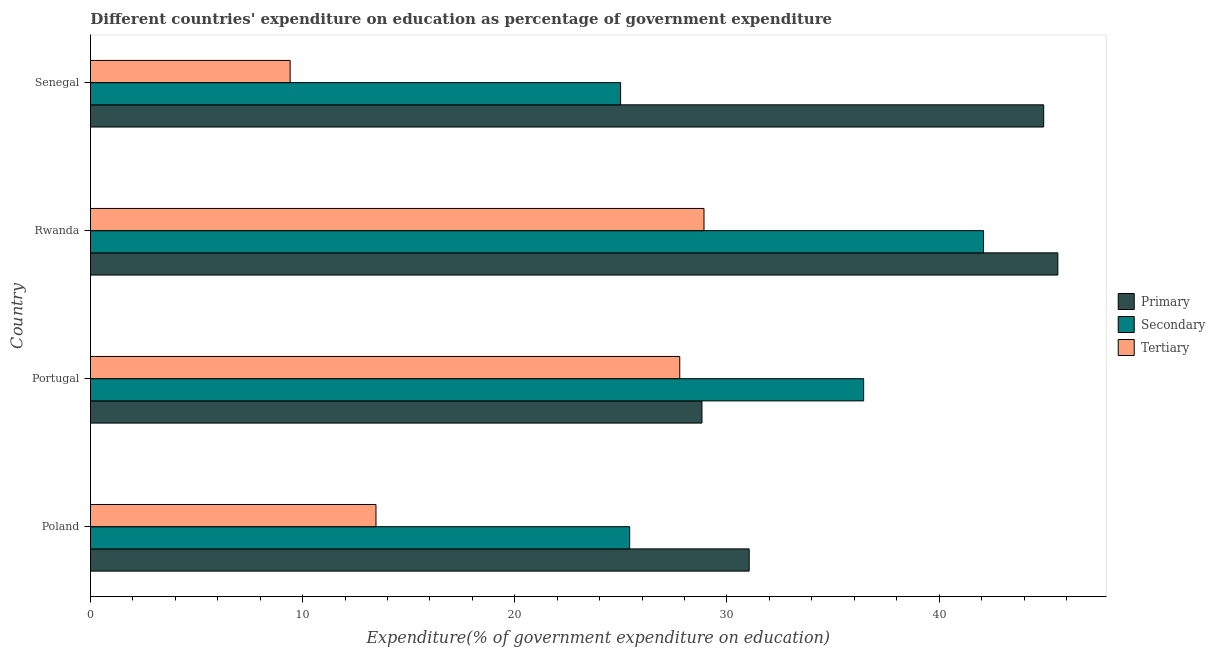How many groups of bars are there?
Keep it short and to the point. 4. Are the number of bars per tick equal to the number of legend labels?
Keep it short and to the point. Yes. What is the label of the 1st group of bars from the top?
Give a very brief answer. Senegal. What is the expenditure on tertiary education in Poland?
Your response must be concise. 13.46. Across all countries, what is the maximum expenditure on secondary education?
Ensure brevity in your answer.  42.09. Across all countries, what is the minimum expenditure on tertiary education?
Your answer should be very brief. 9.41. In which country was the expenditure on primary education maximum?
Ensure brevity in your answer.  Rwanda. In which country was the expenditure on tertiary education minimum?
Your answer should be compact. Senegal. What is the total expenditure on tertiary education in the graph?
Offer a terse response. 79.56. What is the difference between the expenditure on primary education in Rwanda and that in Senegal?
Provide a short and direct response. 0.67. What is the difference between the expenditure on tertiary education in Poland and the expenditure on secondary education in Rwanda?
Your response must be concise. -28.64. What is the average expenditure on primary education per country?
Ensure brevity in your answer.  37.6. What is the difference between the expenditure on tertiary education and expenditure on primary education in Senegal?
Give a very brief answer. -35.52. What is the ratio of the expenditure on tertiary education in Rwanda to that in Senegal?
Give a very brief answer. 3.07. Is the expenditure on tertiary education in Poland less than that in Senegal?
Make the answer very short. No. Is the difference between the expenditure on primary education in Poland and Senegal greater than the difference between the expenditure on tertiary education in Poland and Senegal?
Give a very brief answer. No. What is the difference between the highest and the second highest expenditure on primary education?
Give a very brief answer. 0.67. What is the difference between the highest and the lowest expenditure on secondary education?
Make the answer very short. 17.11. In how many countries, is the expenditure on primary education greater than the average expenditure on primary education taken over all countries?
Provide a short and direct response. 2. What does the 3rd bar from the top in Poland represents?
Give a very brief answer. Primary. What does the 3rd bar from the bottom in Senegal represents?
Offer a terse response. Tertiary. Is it the case that in every country, the sum of the expenditure on primary education and expenditure on secondary education is greater than the expenditure on tertiary education?
Your response must be concise. Yes. How many bars are there?
Give a very brief answer. 12. Are all the bars in the graph horizontal?
Provide a short and direct response. Yes. Does the graph contain any zero values?
Offer a very short reply. No. How many legend labels are there?
Offer a very short reply. 3. How are the legend labels stacked?
Your answer should be compact. Vertical. What is the title of the graph?
Your answer should be very brief. Different countries' expenditure on education as percentage of government expenditure. Does "Taxes on income" appear as one of the legend labels in the graph?
Provide a succinct answer. No. What is the label or title of the X-axis?
Your answer should be compact. Expenditure(% of government expenditure on education). What is the Expenditure(% of government expenditure on education) in Primary in Poland?
Give a very brief answer. 31.05. What is the Expenditure(% of government expenditure on education) in Secondary in Poland?
Keep it short and to the point. 25.41. What is the Expenditure(% of government expenditure on education) in Tertiary in Poland?
Make the answer very short. 13.46. What is the Expenditure(% of government expenditure on education) of Primary in Portugal?
Offer a terse response. 28.82. What is the Expenditure(% of government expenditure on education) in Secondary in Portugal?
Ensure brevity in your answer.  36.44. What is the Expenditure(% of government expenditure on education) of Tertiary in Portugal?
Provide a short and direct response. 27.77. What is the Expenditure(% of government expenditure on education) of Primary in Rwanda?
Ensure brevity in your answer.  45.6. What is the Expenditure(% of government expenditure on education) of Secondary in Rwanda?
Your response must be concise. 42.09. What is the Expenditure(% of government expenditure on education) of Tertiary in Rwanda?
Provide a short and direct response. 28.92. What is the Expenditure(% of government expenditure on education) in Primary in Senegal?
Keep it short and to the point. 44.93. What is the Expenditure(% of government expenditure on education) in Secondary in Senegal?
Ensure brevity in your answer.  24.99. What is the Expenditure(% of government expenditure on education) in Tertiary in Senegal?
Provide a short and direct response. 9.41. Across all countries, what is the maximum Expenditure(% of government expenditure on education) of Primary?
Provide a short and direct response. 45.6. Across all countries, what is the maximum Expenditure(% of government expenditure on education) in Secondary?
Ensure brevity in your answer.  42.09. Across all countries, what is the maximum Expenditure(% of government expenditure on education) of Tertiary?
Your answer should be compact. 28.92. Across all countries, what is the minimum Expenditure(% of government expenditure on education) in Primary?
Make the answer very short. 28.82. Across all countries, what is the minimum Expenditure(% of government expenditure on education) of Secondary?
Give a very brief answer. 24.99. Across all countries, what is the minimum Expenditure(% of government expenditure on education) of Tertiary?
Provide a short and direct response. 9.41. What is the total Expenditure(% of government expenditure on education) in Primary in the graph?
Offer a very short reply. 150.39. What is the total Expenditure(% of government expenditure on education) of Secondary in the graph?
Give a very brief answer. 128.94. What is the total Expenditure(% of government expenditure on education) in Tertiary in the graph?
Your response must be concise. 79.56. What is the difference between the Expenditure(% of government expenditure on education) of Primary in Poland and that in Portugal?
Give a very brief answer. 2.23. What is the difference between the Expenditure(% of government expenditure on education) in Secondary in Poland and that in Portugal?
Keep it short and to the point. -11.03. What is the difference between the Expenditure(% of government expenditure on education) of Tertiary in Poland and that in Portugal?
Offer a very short reply. -14.32. What is the difference between the Expenditure(% of government expenditure on education) of Primary in Poland and that in Rwanda?
Your answer should be very brief. -14.55. What is the difference between the Expenditure(% of government expenditure on education) in Secondary in Poland and that in Rwanda?
Offer a terse response. -16.68. What is the difference between the Expenditure(% of government expenditure on education) in Tertiary in Poland and that in Rwanda?
Your response must be concise. -15.46. What is the difference between the Expenditure(% of government expenditure on education) in Primary in Poland and that in Senegal?
Your answer should be compact. -13.88. What is the difference between the Expenditure(% of government expenditure on education) in Secondary in Poland and that in Senegal?
Offer a very short reply. 0.43. What is the difference between the Expenditure(% of government expenditure on education) of Tertiary in Poland and that in Senegal?
Provide a short and direct response. 4.05. What is the difference between the Expenditure(% of government expenditure on education) in Primary in Portugal and that in Rwanda?
Provide a succinct answer. -16.77. What is the difference between the Expenditure(% of government expenditure on education) in Secondary in Portugal and that in Rwanda?
Your response must be concise. -5.65. What is the difference between the Expenditure(% of government expenditure on education) in Tertiary in Portugal and that in Rwanda?
Give a very brief answer. -1.14. What is the difference between the Expenditure(% of government expenditure on education) in Primary in Portugal and that in Senegal?
Provide a short and direct response. -16.11. What is the difference between the Expenditure(% of government expenditure on education) in Secondary in Portugal and that in Senegal?
Provide a succinct answer. 11.46. What is the difference between the Expenditure(% of government expenditure on education) of Tertiary in Portugal and that in Senegal?
Ensure brevity in your answer.  18.36. What is the difference between the Expenditure(% of government expenditure on education) of Primary in Rwanda and that in Senegal?
Your answer should be very brief. 0.67. What is the difference between the Expenditure(% of government expenditure on education) in Secondary in Rwanda and that in Senegal?
Offer a very short reply. 17.11. What is the difference between the Expenditure(% of government expenditure on education) of Tertiary in Rwanda and that in Senegal?
Make the answer very short. 19.51. What is the difference between the Expenditure(% of government expenditure on education) in Primary in Poland and the Expenditure(% of government expenditure on education) in Secondary in Portugal?
Your answer should be very brief. -5.39. What is the difference between the Expenditure(% of government expenditure on education) in Primary in Poland and the Expenditure(% of government expenditure on education) in Tertiary in Portugal?
Make the answer very short. 3.27. What is the difference between the Expenditure(% of government expenditure on education) of Secondary in Poland and the Expenditure(% of government expenditure on education) of Tertiary in Portugal?
Provide a succinct answer. -2.36. What is the difference between the Expenditure(% of government expenditure on education) of Primary in Poland and the Expenditure(% of government expenditure on education) of Secondary in Rwanda?
Provide a short and direct response. -11.05. What is the difference between the Expenditure(% of government expenditure on education) in Primary in Poland and the Expenditure(% of government expenditure on education) in Tertiary in Rwanda?
Ensure brevity in your answer.  2.13. What is the difference between the Expenditure(% of government expenditure on education) of Secondary in Poland and the Expenditure(% of government expenditure on education) of Tertiary in Rwanda?
Offer a very short reply. -3.5. What is the difference between the Expenditure(% of government expenditure on education) of Primary in Poland and the Expenditure(% of government expenditure on education) of Secondary in Senegal?
Offer a terse response. 6.06. What is the difference between the Expenditure(% of government expenditure on education) of Primary in Poland and the Expenditure(% of government expenditure on education) of Tertiary in Senegal?
Offer a very short reply. 21.64. What is the difference between the Expenditure(% of government expenditure on education) in Secondary in Poland and the Expenditure(% of government expenditure on education) in Tertiary in Senegal?
Ensure brevity in your answer.  16. What is the difference between the Expenditure(% of government expenditure on education) of Primary in Portugal and the Expenditure(% of government expenditure on education) of Secondary in Rwanda?
Offer a terse response. -13.27. What is the difference between the Expenditure(% of government expenditure on education) in Primary in Portugal and the Expenditure(% of government expenditure on education) in Tertiary in Rwanda?
Offer a terse response. -0.1. What is the difference between the Expenditure(% of government expenditure on education) of Secondary in Portugal and the Expenditure(% of government expenditure on education) of Tertiary in Rwanda?
Ensure brevity in your answer.  7.52. What is the difference between the Expenditure(% of government expenditure on education) of Primary in Portugal and the Expenditure(% of government expenditure on education) of Secondary in Senegal?
Your answer should be very brief. 3.83. What is the difference between the Expenditure(% of government expenditure on education) of Primary in Portugal and the Expenditure(% of government expenditure on education) of Tertiary in Senegal?
Ensure brevity in your answer.  19.41. What is the difference between the Expenditure(% of government expenditure on education) in Secondary in Portugal and the Expenditure(% of government expenditure on education) in Tertiary in Senegal?
Offer a terse response. 27.03. What is the difference between the Expenditure(% of government expenditure on education) in Primary in Rwanda and the Expenditure(% of government expenditure on education) in Secondary in Senegal?
Ensure brevity in your answer.  20.61. What is the difference between the Expenditure(% of government expenditure on education) in Primary in Rwanda and the Expenditure(% of government expenditure on education) in Tertiary in Senegal?
Make the answer very short. 36.18. What is the difference between the Expenditure(% of government expenditure on education) in Secondary in Rwanda and the Expenditure(% of government expenditure on education) in Tertiary in Senegal?
Ensure brevity in your answer.  32.68. What is the average Expenditure(% of government expenditure on education) in Primary per country?
Your answer should be very brief. 37.6. What is the average Expenditure(% of government expenditure on education) in Secondary per country?
Provide a succinct answer. 32.23. What is the average Expenditure(% of government expenditure on education) in Tertiary per country?
Offer a terse response. 19.89. What is the difference between the Expenditure(% of government expenditure on education) in Primary and Expenditure(% of government expenditure on education) in Secondary in Poland?
Your response must be concise. 5.63. What is the difference between the Expenditure(% of government expenditure on education) in Primary and Expenditure(% of government expenditure on education) in Tertiary in Poland?
Keep it short and to the point. 17.59. What is the difference between the Expenditure(% of government expenditure on education) of Secondary and Expenditure(% of government expenditure on education) of Tertiary in Poland?
Offer a very short reply. 11.96. What is the difference between the Expenditure(% of government expenditure on education) of Primary and Expenditure(% of government expenditure on education) of Secondary in Portugal?
Your response must be concise. -7.62. What is the difference between the Expenditure(% of government expenditure on education) in Primary and Expenditure(% of government expenditure on education) in Tertiary in Portugal?
Your answer should be very brief. 1.05. What is the difference between the Expenditure(% of government expenditure on education) of Secondary and Expenditure(% of government expenditure on education) of Tertiary in Portugal?
Your response must be concise. 8.67. What is the difference between the Expenditure(% of government expenditure on education) of Primary and Expenditure(% of government expenditure on education) of Secondary in Rwanda?
Offer a very short reply. 3.5. What is the difference between the Expenditure(% of government expenditure on education) of Primary and Expenditure(% of government expenditure on education) of Tertiary in Rwanda?
Provide a succinct answer. 16.68. What is the difference between the Expenditure(% of government expenditure on education) of Secondary and Expenditure(% of government expenditure on education) of Tertiary in Rwanda?
Offer a very short reply. 13.17. What is the difference between the Expenditure(% of government expenditure on education) of Primary and Expenditure(% of government expenditure on education) of Secondary in Senegal?
Give a very brief answer. 19.94. What is the difference between the Expenditure(% of government expenditure on education) in Primary and Expenditure(% of government expenditure on education) in Tertiary in Senegal?
Ensure brevity in your answer.  35.52. What is the difference between the Expenditure(% of government expenditure on education) in Secondary and Expenditure(% of government expenditure on education) in Tertiary in Senegal?
Your answer should be compact. 15.58. What is the ratio of the Expenditure(% of government expenditure on education) of Primary in Poland to that in Portugal?
Keep it short and to the point. 1.08. What is the ratio of the Expenditure(% of government expenditure on education) of Secondary in Poland to that in Portugal?
Offer a terse response. 0.7. What is the ratio of the Expenditure(% of government expenditure on education) of Tertiary in Poland to that in Portugal?
Offer a terse response. 0.48. What is the ratio of the Expenditure(% of government expenditure on education) of Primary in Poland to that in Rwanda?
Your response must be concise. 0.68. What is the ratio of the Expenditure(% of government expenditure on education) in Secondary in Poland to that in Rwanda?
Ensure brevity in your answer.  0.6. What is the ratio of the Expenditure(% of government expenditure on education) in Tertiary in Poland to that in Rwanda?
Your answer should be compact. 0.47. What is the ratio of the Expenditure(% of government expenditure on education) of Primary in Poland to that in Senegal?
Ensure brevity in your answer.  0.69. What is the ratio of the Expenditure(% of government expenditure on education) in Secondary in Poland to that in Senegal?
Your response must be concise. 1.02. What is the ratio of the Expenditure(% of government expenditure on education) in Tertiary in Poland to that in Senegal?
Keep it short and to the point. 1.43. What is the ratio of the Expenditure(% of government expenditure on education) of Primary in Portugal to that in Rwanda?
Give a very brief answer. 0.63. What is the ratio of the Expenditure(% of government expenditure on education) of Secondary in Portugal to that in Rwanda?
Your answer should be compact. 0.87. What is the ratio of the Expenditure(% of government expenditure on education) of Tertiary in Portugal to that in Rwanda?
Make the answer very short. 0.96. What is the ratio of the Expenditure(% of government expenditure on education) of Primary in Portugal to that in Senegal?
Make the answer very short. 0.64. What is the ratio of the Expenditure(% of government expenditure on education) of Secondary in Portugal to that in Senegal?
Offer a terse response. 1.46. What is the ratio of the Expenditure(% of government expenditure on education) in Tertiary in Portugal to that in Senegal?
Make the answer very short. 2.95. What is the ratio of the Expenditure(% of government expenditure on education) in Primary in Rwanda to that in Senegal?
Offer a very short reply. 1.01. What is the ratio of the Expenditure(% of government expenditure on education) in Secondary in Rwanda to that in Senegal?
Your answer should be compact. 1.68. What is the ratio of the Expenditure(% of government expenditure on education) of Tertiary in Rwanda to that in Senegal?
Offer a terse response. 3.07. What is the difference between the highest and the second highest Expenditure(% of government expenditure on education) in Primary?
Give a very brief answer. 0.67. What is the difference between the highest and the second highest Expenditure(% of government expenditure on education) in Secondary?
Provide a succinct answer. 5.65. What is the difference between the highest and the second highest Expenditure(% of government expenditure on education) of Tertiary?
Provide a succinct answer. 1.14. What is the difference between the highest and the lowest Expenditure(% of government expenditure on education) in Primary?
Your answer should be compact. 16.77. What is the difference between the highest and the lowest Expenditure(% of government expenditure on education) in Secondary?
Keep it short and to the point. 17.11. What is the difference between the highest and the lowest Expenditure(% of government expenditure on education) in Tertiary?
Keep it short and to the point. 19.51. 